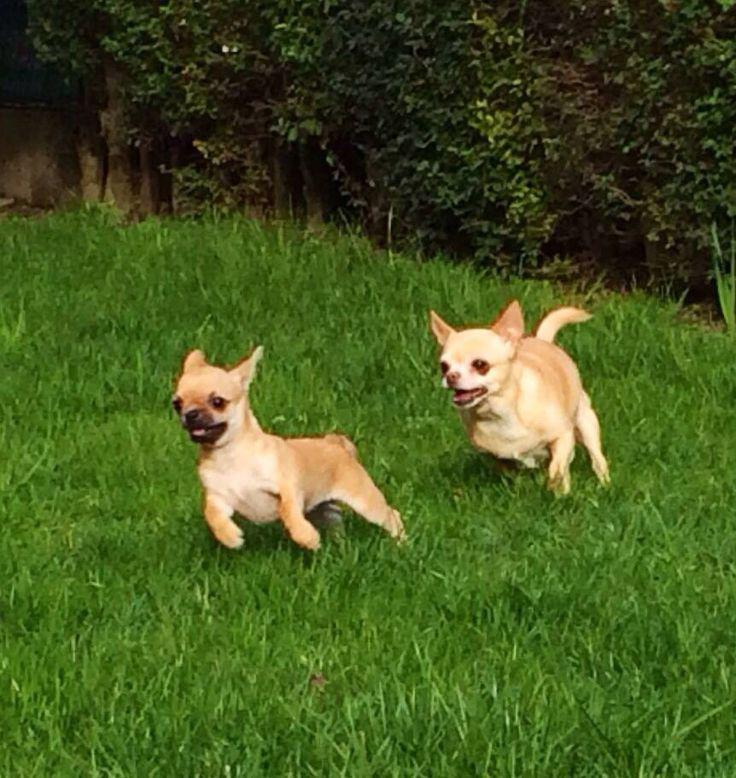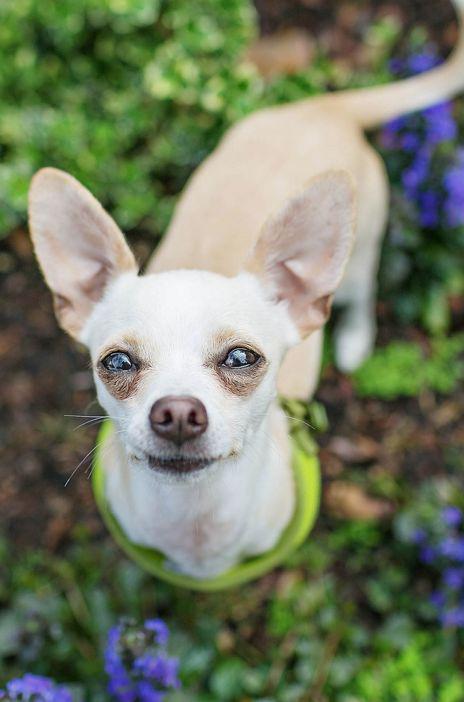The first image is the image on the left, the second image is the image on the right. Considering the images on both sides, is "There are a total of two dogs between both images." valid? Answer yes or no. No. The first image is the image on the left, the second image is the image on the right. Given the left and right images, does the statement "The left photo depicts two or more dogs outside in the grass." hold true? Answer yes or no. Yes. 